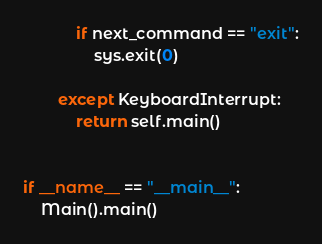Convert code to text. <code><loc_0><loc_0><loc_500><loc_500><_Python_>            if next_command == "exit":
                sys.exit(0)

        except KeyboardInterrupt:
            return self.main()


if __name__ == "__main__":
    Main().main()
</code> 